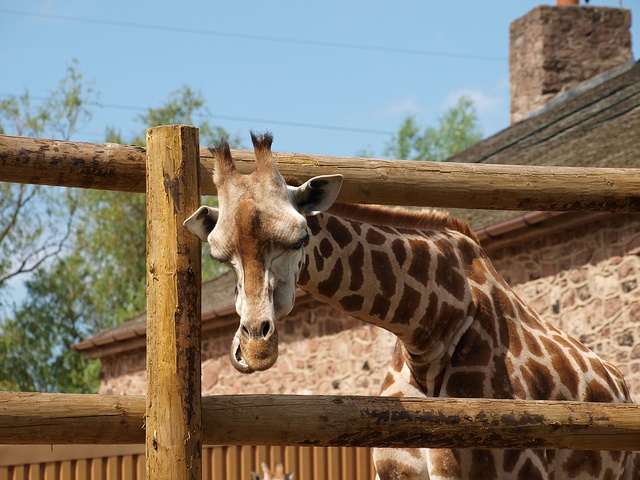Describe the objects in this image and their specific colors. I can see a giraffe in lightblue, black, maroon, and gray tones in this image. 